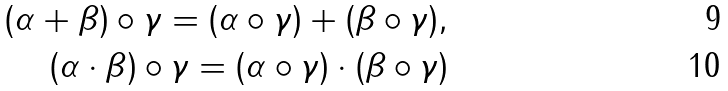<formula> <loc_0><loc_0><loc_500><loc_500>( \alpha + \beta ) \circ \gamma = ( \alpha \circ \gamma ) + ( \beta \circ \gamma ) , \\ ( \alpha \cdot \beta ) \circ \gamma = ( \alpha \circ \gamma ) \cdot ( \beta \circ \gamma )</formula> 